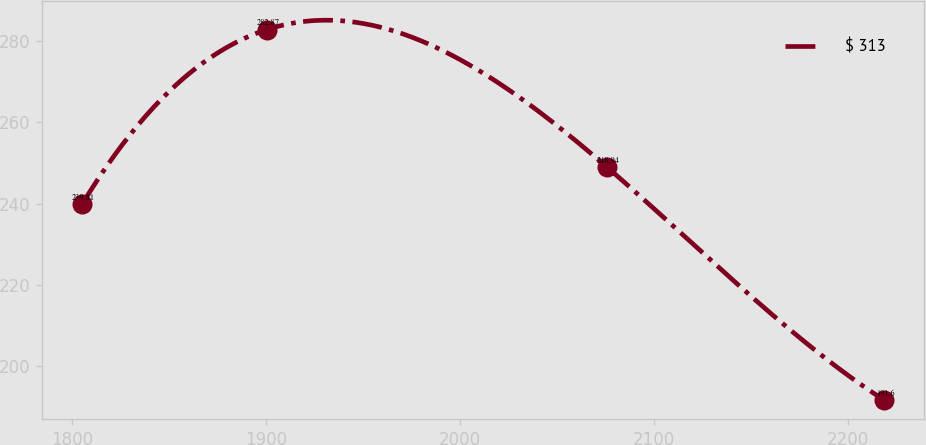Convert chart to OTSL. <chart><loc_0><loc_0><loc_500><loc_500><line_chart><ecel><fcel>$ 313<nl><fcel>1805.31<fcel>239.81<nl><fcel>1900.71<fcel>282.87<nl><fcel>2075.99<fcel>248.94<nl><fcel>2218.7<fcel>191.6<nl></chart> 